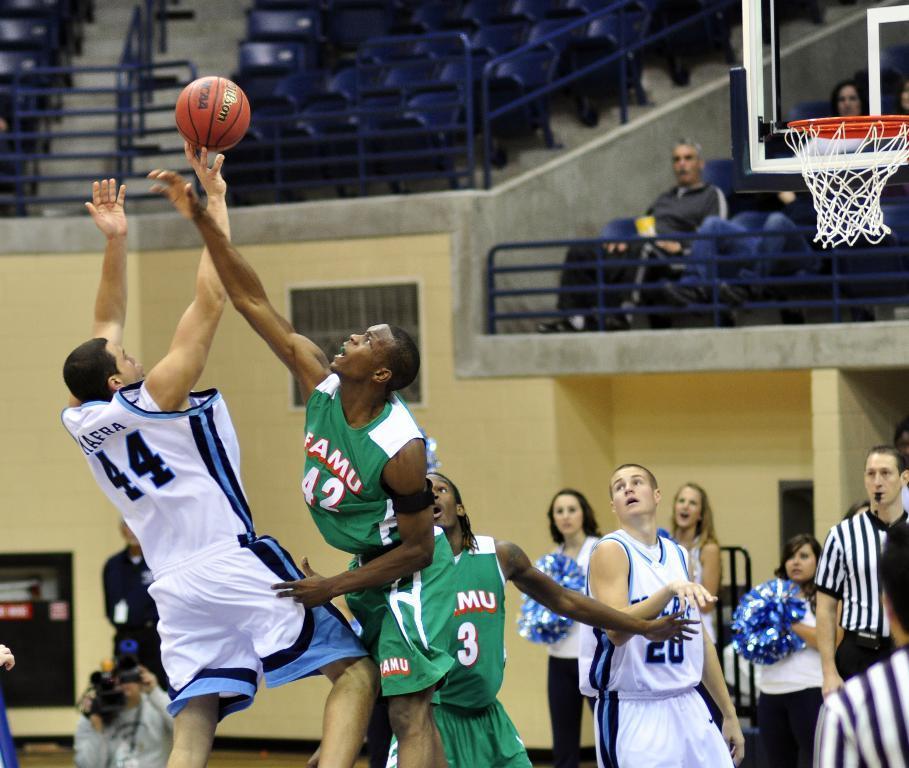Describe this image in one or two sentences. In this image we can see people playing basketball. In the background of the image there are chairs, fencing. There are people sitting on chairs. To the right side of the image there is a basketball net. 